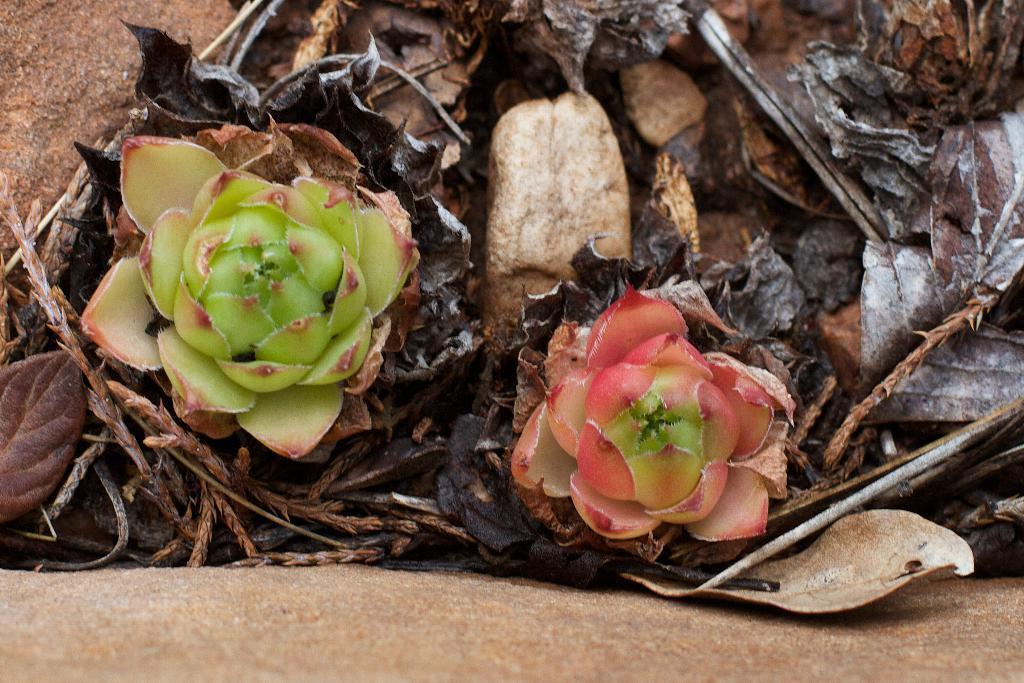In one or two sentences, can you explain what this image depicts? In this image we can see flowers and dried leaves. 